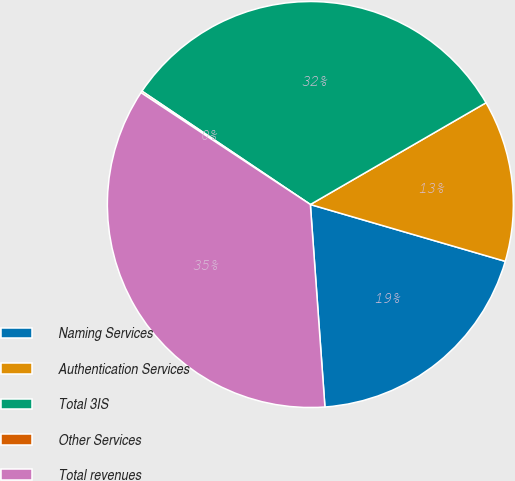Convert chart. <chart><loc_0><loc_0><loc_500><loc_500><pie_chart><fcel>Naming Services<fcel>Authentication Services<fcel>Total 3IS<fcel>Other Services<fcel>Total revenues<nl><fcel>19.34%<fcel>12.87%<fcel>32.21%<fcel>0.14%<fcel>35.43%<nl></chart> 